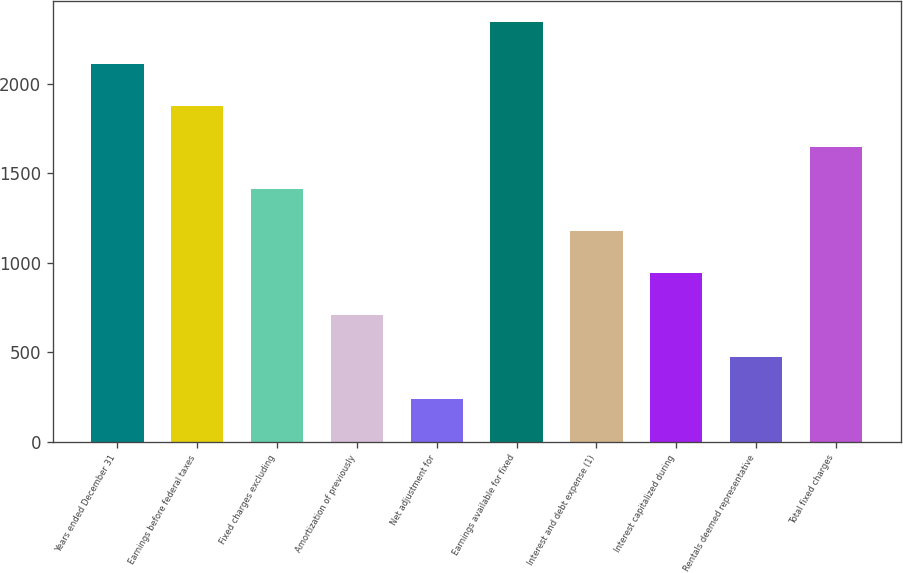<chart> <loc_0><loc_0><loc_500><loc_500><bar_chart><fcel>Years ended December 31<fcel>Earnings before federal taxes<fcel>Fixed charges excluding<fcel>Amortization of previously<fcel>Net adjustment for<fcel>Earnings available for fixed<fcel>Interest and debt expense (1)<fcel>Interest capitalized during<fcel>Rentals deemed representative<fcel>Total fixed charges<nl><fcel>2111.76<fcel>1877.52<fcel>1409.04<fcel>706.32<fcel>237.84<fcel>2346<fcel>1174.8<fcel>940.56<fcel>472.08<fcel>1643.28<nl></chart> 